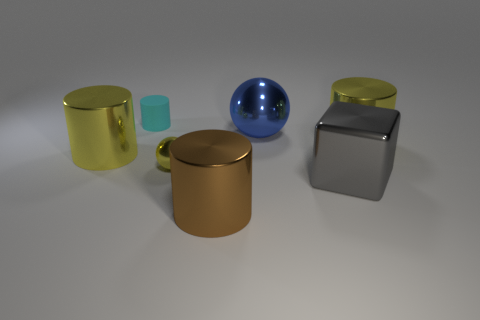Subtract 1 cylinders. How many cylinders are left? 3 Add 2 small brown shiny cubes. How many objects exist? 9 Subtract all balls. How many objects are left? 5 Add 4 yellow balls. How many yellow balls are left? 5 Add 2 tiny cyan objects. How many tiny cyan objects exist? 3 Subtract 0 green spheres. How many objects are left? 7 Subtract all big brown shiny things. Subtract all gray metal objects. How many objects are left? 5 